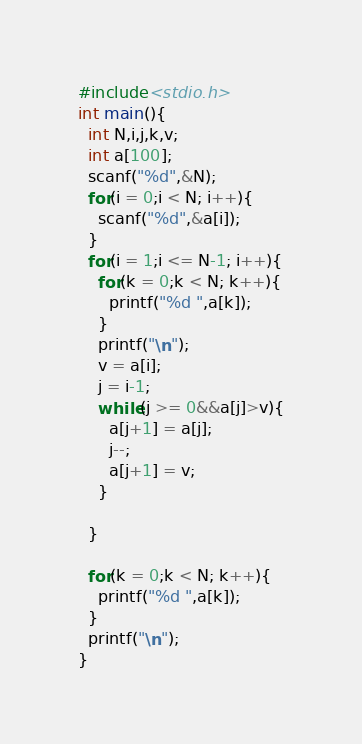<code> <loc_0><loc_0><loc_500><loc_500><_C_>#include<stdio.h>
int main(){
  int N,i,j,k,v;
  int a[100];
  scanf("%d",&N);
  for(i = 0;i < N; i++){
    scanf("%d",&a[i]);
  }
  for(i = 1;i <= N-1; i++){
    for(k = 0;k < N; k++){
      printf("%d ",a[k]);
    }
    printf("\n");
    v = a[i];
    j = i-1;
    while(j >= 0&&a[j]>v){
      a[j+1] = a[j];
      j--;
      a[j+1] = v;
    }
    
  }
  
  for(k = 0;k < N; k++){
    printf("%d ",a[k]);
  }
  printf("\n");
}

</code> 